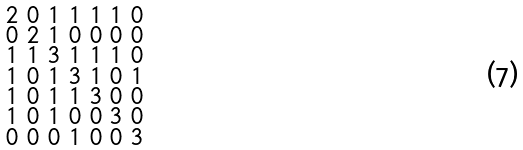<formula> <loc_0><loc_0><loc_500><loc_500>\begin{smallmatrix} 2 & 0 & 1 & 1 & 1 & 1 & 0 \\ 0 & 2 & 1 & 0 & 0 & 0 & 0 \\ 1 & 1 & 3 & 1 & 1 & 1 & 0 \\ 1 & 0 & 1 & 3 & 1 & 0 & 1 \\ 1 & 0 & 1 & 1 & 3 & 0 & 0 \\ 1 & 0 & 1 & 0 & 0 & 3 & 0 \\ 0 & 0 & 0 & 1 & 0 & 0 & 3 \end{smallmatrix}</formula> 